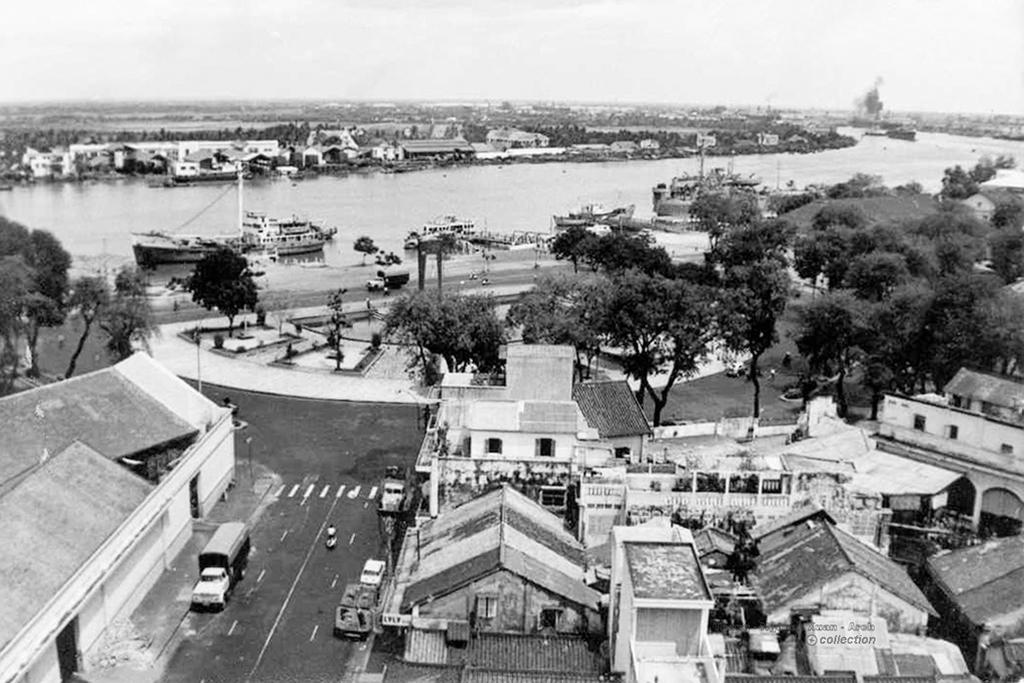What type of location is depicted in the image? The image is of a city. What structures can be seen in the city? There are buildings in the image. How do people and vehicles move around in the city? There are roads in the image for people and vehicles to move around. What mode of transportation can be seen on the water in the image? There are boats on the water in the image. What natural elements are present in the city? There are trees in the image. What part of the sky is visible in the image? The sky is visible in the image. Is there any additional marking on the image? Yes, there is a watermark on the image. How many cattle are grazing in the city in the image? There are no cattle present in the image; it depicts a city with various urban elements. 